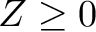Convert formula to latex. <formula><loc_0><loc_0><loc_500><loc_500>Z \geq 0</formula> 